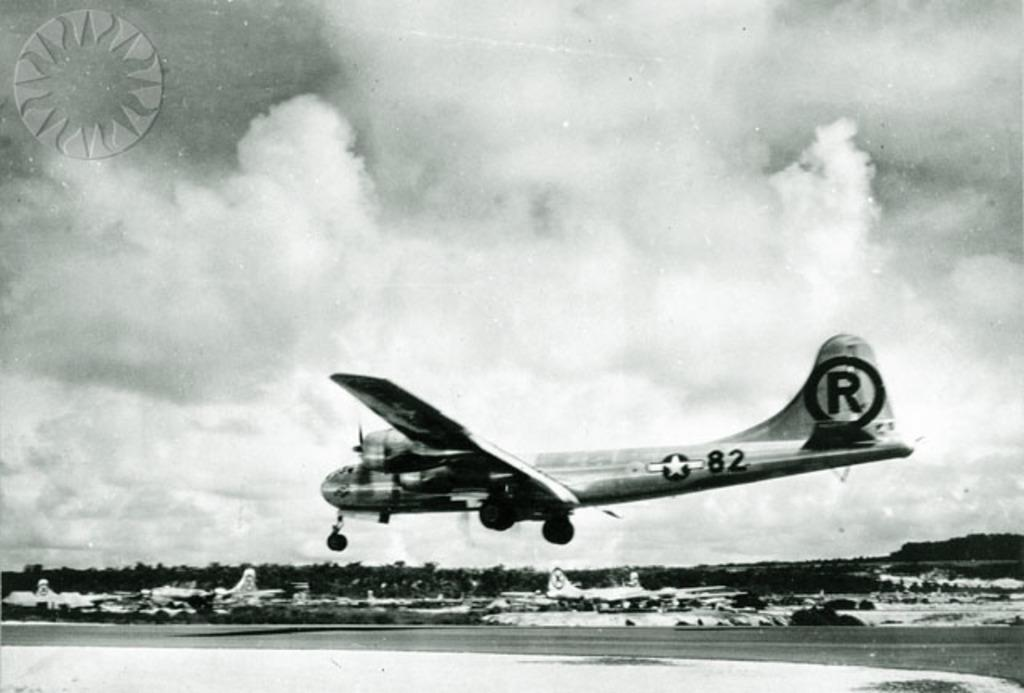What is the main subject of the image? The main subject of the image is planes. What can be seen in the background of the image? There are clouds and trees in the background of the image. How is the image presented? The photograph is in black and white. Is there any text or symbol present in the image? Yes, there is a logo at the top of the image. What type of cracker is being used to take the photograph in the image? There is no cracker present in the image, and the image is not a photograph being taken by a cracker. What division of planes is depicted in the image? The image does not depict a specific division of planes; it simply shows planes in general. 